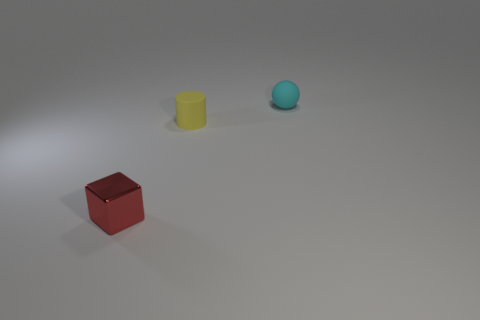Add 3 large blue matte cubes. How many objects exist? 6 Subtract all cylinders. How many objects are left? 2 Add 1 tiny rubber cylinders. How many tiny rubber cylinders are left? 2 Add 1 blue shiny cylinders. How many blue shiny cylinders exist? 1 Subtract 0 gray spheres. How many objects are left? 3 Subtract all cyan rubber balls. Subtract all small red blocks. How many objects are left? 1 